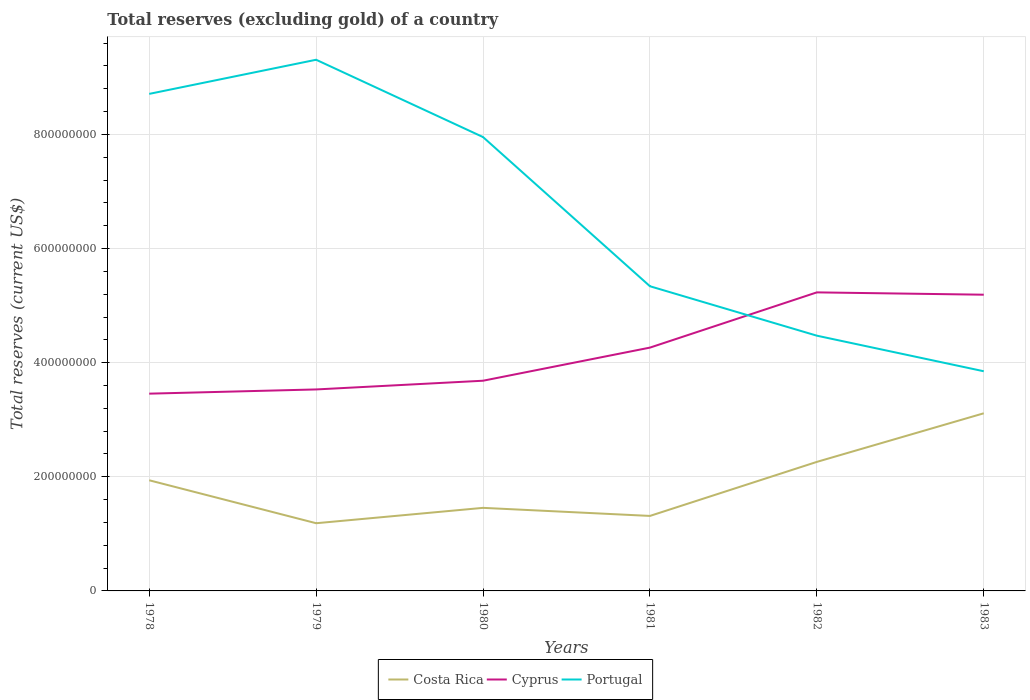How many different coloured lines are there?
Your answer should be compact. 3. Across all years, what is the maximum total reserves (excluding gold) in Costa Rica?
Your response must be concise. 1.19e+08. In which year was the total reserves (excluding gold) in Costa Rica maximum?
Offer a terse response. 1979. What is the total total reserves (excluding gold) in Portugal in the graph?
Offer a terse response. 4.24e+08. What is the difference between the highest and the second highest total reserves (excluding gold) in Portugal?
Provide a succinct answer. 5.46e+08. Is the total reserves (excluding gold) in Costa Rica strictly greater than the total reserves (excluding gold) in Portugal over the years?
Give a very brief answer. Yes. How many lines are there?
Give a very brief answer. 3. Are the values on the major ticks of Y-axis written in scientific E-notation?
Your answer should be very brief. No. How many legend labels are there?
Your answer should be very brief. 3. What is the title of the graph?
Offer a terse response. Total reserves (excluding gold) of a country. Does "Kyrgyz Republic" appear as one of the legend labels in the graph?
Keep it short and to the point. No. What is the label or title of the X-axis?
Offer a terse response. Years. What is the label or title of the Y-axis?
Offer a terse response. Total reserves (current US$). What is the Total reserves (current US$) in Costa Rica in 1978?
Your answer should be compact. 1.94e+08. What is the Total reserves (current US$) in Cyprus in 1978?
Your answer should be very brief. 3.46e+08. What is the Total reserves (current US$) of Portugal in 1978?
Your answer should be very brief. 8.71e+08. What is the Total reserves (current US$) of Costa Rica in 1979?
Keep it short and to the point. 1.19e+08. What is the Total reserves (current US$) of Cyprus in 1979?
Keep it short and to the point. 3.53e+08. What is the Total reserves (current US$) of Portugal in 1979?
Your answer should be very brief. 9.31e+08. What is the Total reserves (current US$) of Costa Rica in 1980?
Make the answer very short. 1.46e+08. What is the Total reserves (current US$) of Cyprus in 1980?
Offer a terse response. 3.68e+08. What is the Total reserves (current US$) of Portugal in 1980?
Give a very brief answer. 7.95e+08. What is the Total reserves (current US$) in Costa Rica in 1981?
Your answer should be compact. 1.31e+08. What is the Total reserves (current US$) in Cyprus in 1981?
Make the answer very short. 4.26e+08. What is the Total reserves (current US$) of Portugal in 1981?
Your answer should be very brief. 5.34e+08. What is the Total reserves (current US$) of Costa Rica in 1982?
Your response must be concise. 2.26e+08. What is the Total reserves (current US$) in Cyprus in 1982?
Keep it short and to the point. 5.23e+08. What is the Total reserves (current US$) of Portugal in 1982?
Ensure brevity in your answer.  4.47e+08. What is the Total reserves (current US$) in Costa Rica in 1983?
Offer a terse response. 3.11e+08. What is the Total reserves (current US$) in Cyprus in 1983?
Offer a very short reply. 5.19e+08. What is the Total reserves (current US$) of Portugal in 1983?
Offer a terse response. 3.85e+08. Across all years, what is the maximum Total reserves (current US$) in Costa Rica?
Provide a succinct answer. 3.11e+08. Across all years, what is the maximum Total reserves (current US$) in Cyprus?
Provide a succinct answer. 5.23e+08. Across all years, what is the maximum Total reserves (current US$) of Portugal?
Your answer should be very brief. 9.31e+08. Across all years, what is the minimum Total reserves (current US$) in Costa Rica?
Offer a very short reply. 1.19e+08. Across all years, what is the minimum Total reserves (current US$) in Cyprus?
Ensure brevity in your answer.  3.46e+08. Across all years, what is the minimum Total reserves (current US$) of Portugal?
Your answer should be very brief. 3.85e+08. What is the total Total reserves (current US$) in Costa Rica in the graph?
Ensure brevity in your answer.  1.13e+09. What is the total Total reserves (current US$) in Cyprus in the graph?
Your answer should be compact. 2.54e+09. What is the total Total reserves (current US$) in Portugal in the graph?
Provide a succinct answer. 3.96e+09. What is the difference between the Total reserves (current US$) in Costa Rica in 1978 and that in 1979?
Ensure brevity in your answer.  7.53e+07. What is the difference between the Total reserves (current US$) of Cyprus in 1978 and that in 1979?
Provide a short and direct response. -7.38e+06. What is the difference between the Total reserves (current US$) in Portugal in 1978 and that in 1979?
Provide a succinct answer. -5.98e+07. What is the difference between the Total reserves (current US$) in Costa Rica in 1978 and that in 1980?
Your answer should be very brief. 4.83e+07. What is the difference between the Total reserves (current US$) of Cyprus in 1978 and that in 1980?
Offer a very short reply. -2.27e+07. What is the difference between the Total reserves (current US$) of Portugal in 1978 and that in 1980?
Offer a terse response. 7.57e+07. What is the difference between the Total reserves (current US$) in Costa Rica in 1978 and that in 1981?
Your answer should be very brief. 6.25e+07. What is the difference between the Total reserves (current US$) in Cyprus in 1978 and that in 1981?
Your answer should be compact. -8.07e+07. What is the difference between the Total reserves (current US$) of Portugal in 1978 and that in 1981?
Your answer should be very brief. 3.37e+08. What is the difference between the Total reserves (current US$) of Costa Rica in 1978 and that in 1982?
Offer a very short reply. -3.22e+07. What is the difference between the Total reserves (current US$) in Cyprus in 1978 and that in 1982?
Your answer should be very brief. -1.77e+08. What is the difference between the Total reserves (current US$) of Portugal in 1978 and that in 1982?
Give a very brief answer. 4.24e+08. What is the difference between the Total reserves (current US$) in Costa Rica in 1978 and that in 1983?
Make the answer very short. -1.17e+08. What is the difference between the Total reserves (current US$) of Cyprus in 1978 and that in 1983?
Offer a very short reply. -1.73e+08. What is the difference between the Total reserves (current US$) in Portugal in 1978 and that in 1983?
Provide a succinct answer. 4.86e+08. What is the difference between the Total reserves (current US$) of Costa Rica in 1979 and that in 1980?
Your answer should be compact. -2.69e+07. What is the difference between the Total reserves (current US$) of Cyprus in 1979 and that in 1980?
Offer a very short reply. -1.53e+07. What is the difference between the Total reserves (current US$) of Portugal in 1979 and that in 1980?
Your response must be concise. 1.35e+08. What is the difference between the Total reserves (current US$) of Costa Rica in 1979 and that in 1981?
Keep it short and to the point. -1.28e+07. What is the difference between the Total reserves (current US$) of Cyprus in 1979 and that in 1981?
Your answer should be very brief. -7.33e+07. What is the difference between the Total reserves (current US$) in Portugal in 1979 and that in 1981?
Your response must be concise. 3.97e+08. What is the difference between the Total reserves (current US$) in Costa Rica in 1979 and that in 1982?
Make the answer very short. -1.07e+08. What is the difference between the Total reserves (current US$) in Cyprus in 1979 and that in 1982?
Give a very brief answer. -1.70e+08. What is the difference between the Total reserves (current US$) in Portugal in 1979 and that in 1982?
Ensure brevity in your answer.  4.84e+08. What is the difference between the Total reserves (current US$) of Costa Rica in 1979 and that in 1983?
Give a very brief answer. -1.93e+08. What is the difference between the Total reserves (current US$) of Cyprus in 1979 and that in 1983?
Your answer should be very brief. -1.66e+08. What is the difference between the Total reserves (current US$) in Portugal in 1979 and that in 1983?
Give a very brief answer. 5.46e+08. What is the difference between the Total reserves (current US$) of Costa Rica in 1980 and that in 1981?
Provide a short and direct response. 1.42e+07. What is the difference between the Total reserves (current US$) of Cyprus in 1980 and that in 1981?
Keep it short and to the point. -5.80e+07. What is the difference between the Total reserves (current US$) of Portugal in 1980 and that in 1981?
Ensure brevity in your answer.  2.61e+08. What is the difference between the Total reserves (current US$) in Costa Rica in 1980 and that in 1982?
Keep it short and to the point. -8.05e+07. What is the difference between the Total reserves (current US$) in Cyprus in 1980 and that in 1982?
Provide a succinct answer. -1.55e+08. What is the difference between the Total reserves (current US$) of Portugal in 1980 and that in 1982?
Give a very brief answer. 3.48e+08. What is the difference between the Total reserves (current US$) in Costa Rica in 1980 and that in 1983?
Your answer should be compact. -1.66e+08. What is the difference between the Total reserves (current US$) of Cyprus in 1980 and that in 1983?
Your answer should be compact. -1.51e+08. What is the difference between the Total reserves (current US$) of Portugal in 1980 and that in 1983?
Make the answer very short. 4.10e+08. What is the difference between the Total reserves (current US$) of Costa Rica in 1981 and that in 1982?
Your response must be concise. -9.47e+07. What is the difference between the Total reserves (current US$) in Cyprus in 1981 and that in 1982?
Give a very brief answer. -9.68e+07. What is the difference between the Total reserves (current US$) in Portugal in 1981 and that in 1982?
Your response must be concise. 8.66e+07. What is the difference between the Total reserves (current US$) in Costa Rica in 1981 and that in 1983?
Your answer should be very brief. -1.80e+08. What is the difference between the Total reserves (current US$) in Cyprus in 1981 and that in 1983?
Provide a short and direct response. -9.27e+07. What is the difference between the Total reserves (current US$) of Portugal in 1981 and that in 1983?
Offer a very short reply. 1.49e+08. What is the difference between the Total reserves (current US$) in Costa Rica in 1982 and that in 1983?
Your answer should be very brief. -8.52e+07. What is the difference between the Total reserves (current US$) of Cyprus in 1982 and that in 1983?
Your answer should be very brief. 4.10e+06. What is the difference between the Total reserves (current US$) of Portugal in 1982 and that in 1983?
Your answer should be very brief. 6.23e+07. What is the difference between the Total reserves (current US$) of Costa Rica in 1978 and the Total reserves (current US$) of Cyprus in 1979?
Your response must be concise. -1.59e+08. What is the difference between the Total reserves (current US$) in Costa Rica in 1978 and the Total reserves (current US$) in Portugal in 1979?
Your answer should be very brief. -7.37e+08. What is the difference between the Total reserves (current US$) of Cyprus in 1978 and the Total reserves (current US$) of Portugal in 1979?
Give a very brief answer. -5.85e+08. What is the difference between the Total reserves (current US$) in Costa Rica in 1978 and the Total reserves (current US$) in Cyprus in 1980?
Give a very brief answer. -1.74e+08. What is the difference between the Total reserves (current US$) in Costa Rica in 1978 and the Total reserves (current US$) in Portugal in 1980?
Give a very brief answer. -6.01e+08. What is the difference between the Total reserves (current US$) in Cyprus in 1978 and the Total reserves (current US$) in Portugal in 1980?
Your answer should be very brief. -4.50e+08. What is the difference between the Total reserves (current US$) of Costa Rica in 1978 and the Total reserves (current US$) of Cyprus in 1981?
Your response must be concise. -2.32e+08. What is the difference between the Total reserves (current US$) of Costa Rica in 1978 and the Total reserves (current US$) of Portugal in 1981?
Offer a very short reply. -3.40e+08. What is the difference between the Total reserves (current US$) of Cyprus in 1978 and the Total reserves (current US$) of Portugal in 1981?
Ensure brevity in your answer.  -1.88e+08. What is the difference between the Total reserves (current US$) of Costa Rica in 1978 and the Total reserves (current US$) of Cyprus in 1982?
Offer a terse response. -3.29e+08. What is the difference between the Total reserves (current US$) of Costa Rica in 1978 and the Total reserves (current US$) of Portugal in 1982?
Keep it short and to the point. -2.53e+08. What is the difference between the Total reserves (current US$) of Cyprus in 1978 and the Total reserves (current US$) of Portugal in 1982?
Give a very brief answer. -1.02e+08. What is the difference between the Total reserves (current US$) in Costa Rica in 1978 and the Total reserves (current US$) in Cyprus in 1983?
Give a very brief answer. -3.25e+08. What is the difference between the Total reserves (current US$) in Costa Rica in 1978 and the Total reserves (current US$) in Portugal in 1983?
Offer a terse response. -1.91e+08. What is the difference between the Total reserves (current US$) in Cyprus in 1978 and the Total reserves (current US$) in Portugal in 1983?
Offer a terse response. -3.93e+07. What is the difference between the Total reserves (current US$) of Costa Rica in 1979 and the Total reserves (current US$) of Cyprus in 1980?
Give a very brief answer. -2.50e+08. What is the difference between the Total reserves (current US$) of Costa Rica in 1979 and the Total reserves (current US$) of Portugal in 1980?
Offer a very short reply. -6.77e+08. What is the difference between the Total reserves (current US$) of Cyprus in 1979 and the Total reserves (current US$) of Portugal in 1980?
Provide a succinct answer. -4.42e+08. What is the difference between the Total reserves (current US$) of Costa Rica in 1979 and the Total reserves (current US$) of Cyprus in 1981?
Ensure brevity in your answer.  -3.08e+08. What is the difference between the Total reserves (current US$) of Costa Rica in 1979 and the Total reserves (current US$) of Portugal in 1981?
Offer a terse response. -4.15e+08. What is the difference between the Total reserves (current US$) in Cyprus in 1979 and the Total reserves (current US$) in Portugal in 1981?
Your response must be concise. -1.81e+08. What is the difference between the Total reserves (current US$) of Costa Rica in 1979 and the Total reserves (current US$) of Cyprus in 1982?
Provide a succinct answer. -4.05e+08. What is the difference between the Total reserves (current US$) in Costa Rica in 1979 and the Total reserves (current US$) in Portugal in 1982?
Provide a short and direct response. -3.29e+08. What is the difference between the Total reserves (current US$) in Cyprus in 1979 and the Total reserves (current US$) in Portugal in 1982?
Ensure brevity in your answer.  -9.42e+07. What is the difference between the Total reserves (current US$) of Costa Rica in 1979 and the Total reserves (current US$) of Cyprus in 1983?
Give a very brief answer. -4.00e+08. What is the difference between the Total reserves (current US$) of Costa Rica in 1979 and the Total reserves (current US$) of Portugal in 1983?
Your answer should be very brief. -2.66e+08. What is the difference between the Total reserves (current US$) of Cyprus in 1979 and the Total reserves (current US$) of Portugal in 1983?
Your answer should be compact. -3.19e+07. What is the difference between the Total reserves (current US$) of Costa Rica in 1980 and the Total reserves (current US$) of Cyprus in 1981?
Your answer should be very brief. -2.81e+08. What is the difference between the Total reserves (current US$) in Costa Rica in 1980 and the Total reserves (current US$) in Portugal in 1981?
Make the answer very short. -3.88e+08. What is the difference between the Total reserves (current US$) of Cyprus in 1980 and the Total reserves (current US$) of Portugal in 1981?
Make the answer very short. -1.66e+08. What is the difference between the Total reserves (current US$) of Costa Rica in 1980 and the Total reserves (current US$) of Cyprus in 1982?
Your answer should be compact. -3.78e+08. What is the difference between the Total reserves (current US$) of Costa Rica in 1980 and the Total reserves (current US$) of Portugal in 1982?
Your answer should be very brief. -3.02e+08. What is the difference between the Total reserves (current US$) in Cyprus in 1980 and the Total reserves (current US$) in Portugal in 1982?
Provide a succinct answer. -7.89e+07. What is the difference between the Total reserves (current US$) of Costa Rica in 1980 and the Total reserves (current US$) of Cyprus in 1983?
Offer a very short reply. -3.74e+08. What is the difference between the Total reserves (current US$) in Costa Rica in 1980 and the Total reserves (current US$) in Portugal in 1983?
Your answer should be very brief. -2.39e+08. What is the difference between the Total reserves (current US$) of Cyprus in 1980 and the Total reserves (current US$) of Portugal in 1983?
Keep it short and to the point. -1.66e+07. What is the difference between the Total reserves (current US$) in Costa Rica in 1981 and the Total reserves (current US$) in Cyprus in 1982?
Give a very brief answer. -3.92e+08. What is the difference between the Total reserves (current US$) of Costa Rica in 1981 and the Total reserves (current US$) of Portugal in 1982?
Your response must be concise. -3.16e+08. What is the difference between the Total reserves (current US$) in Cyprus in 1981 and the Total reserves (current US$) in Portugal in 1982?
Provide a succinct answer. -2.09e+07. What is the difference between the Total reserves (current US$) in Costa Rica in 1981 and the Total reserves (current US$) in Cyprus in 1983?
Provide a succinct answer. -3.88e+08. What is the difference between the Total reserves (current US$) in Costa Rica in 1981 and the Total reserves (current US$) in Portugal in 1983?
Ensure brevity in your answer.  -2.54e+08. What is the difference between the Total reserves (current US$) of Cyprus in 1981 and the Total reserves (current US$) of Portugal in 1983?
Your answer should be very brief. 4.14e+07. What is the difference between the Total reserves (current US$) of Costa Rica in 1982 and the Total reserves (current US$) of Cyprus in 1983?
Provide a succinct answer. -2.93e+08. What is the difference between the Total reserves (current US$) in Costa Rica in 1982 and the Total reserves (current US$) in Portugal in 1983?
Keep it short and to the point. -1.59e+08. What is the difference between the Total reserves (current US$) in Cyprus in 1982 and the Total reserves (current US$) in Portugal in 1983?
Ensure brevity in your answer.  1.38e+08. What is the average Total reserves (current US$) of Costa Rica per year?
Ensure brevity in your answer.  1.88e+08. What is the average Total reserves (current US$) in Cyprus per year?
Your answer should be compact. 4.23e+08. What is the average Total reserves (current US$) of Portugal per year?
Your response must be concise. 6.61e+08. In the year 1978, what is the difference between the Total reserves (current US$) of Costa Rica and Total reserves (current US$) of Cyprus?
Provide a succinct answer. -1.52e+08. In the year 1978, what is the difference between the Total reserves (current US$) of Costa Rica and Total reserves (current US$) of Portugal?
Provide a short and direct response. -6.77e+08. In the year 1978, what is the difference between the Total reserves (current US$) in Cyprus and Total reserves (current US$) in Portugal?
Your answer should be very brief. -5.25e+08. In the year 1979, what is the difference between the Total reserves (current US$) of Costa Rica and Total reserves (current US$) of Cyprus?
Your answer should be compact. -2.34e+08. In the year 1979, what is the difference between the Total reserves (current US$) in Costa Rica and Total reserves (current US$) in Portugal?
Offer a very short reply. -8.12e+08. In the year 1979, what is the difference between the Total reserves (current US$) of Cyprus and Total reserves (current US$) of Portugal?
Ensure brevity in your answer.  -5.78e+08. In the year 1980, what is the difference between the Total reserves (current US$) in Costa Rica and Total reserves (current US$) in Cyprus?
Your answer should be very brief. -2.23e+08. In the year 1980, what is the difference between the Total reserves (current US$) in Costa Rica and Total reserves (current US$) in Portugal?
Your response must be concise. -6.50e+08. In the year 1980, what is the difference between the Total reserves (current US$) of Cyprus and Total reserves (current US$) of Portugal?
Offer a very short reply. -4.27e+08. In the year 1981, what is the difference between the Total reserves (current US$) of Costa Rica and Total reserves (current US$) of Cyprus?
Give a very brief answer. -2.95e+08. In the year 1981, what is the difference between the Total reserves (current US$) in Costa Rica and Total reserves (current US$) in Portugal?
Offer a terse response. -4.02e+08. In the year 1981, what is the difference between the Total reserves (current US$) in Cyprus and Total reserves (current US$) in Portugal?
Provide a short and direct response. -1.08e+08. In the year 1982, what is the difference between the Total reserves (current US$) in Costa Rica and Total reserves (current US$) in Cyprus?
Ensure brevity in your answer.  -2.97e+08. In the year 1982, what is the difference between the Total reserves (current US$) in Costa Rica and Total reserves (current US$) in Portugal?
Your response must be concise. -2.21e+08. In the year 1982, what is the difference between the Total reserves (current US$) of Cyprus and Total reserves (current US$) of Portugal?
Offer a very short reply. 7.59e+07. In the year 1983, what is the difference between the Total reserves (current US$) of Costa Rica and Total reserves (current US$) of Cyprus?
Make the answer very short. -2.08e+08. In the year 1983, what is the difference between the Total reserves (current US$) of Costa Rica and Total reserves (current US$) of Portugal?
Ensure brevity in your answer.  -7.37e+07. In the year 1983, what is the difference between the Total reserves (current US$) in Cyprus and Total reserves (current US$) in Portugal?
Provide a short and direct response. 1.34e+08. What is the ratio of the Total reserves (current US$) of Costa Rica in 1978 to that in 1979?
Keep it short and to the point. 1.63. What is the ratio of the Total reserves (current US$) of Cyprus in 1978 to that in 1979?
Make the answer very short. 0.98. What is the ratio of the Total reserves (current US$) in Portugal in 1978 to that in 1979?
Offer a very short reply. 0.94. What is the ratio of the Total reserves (current US$) in Costa Rica in 1978 to that in 1980?
Provide a short and direct response. 1.33. What is the ratio of the Total reserves (current US$) of Cyprus in 1978 to that in 1980?
Your answer should be compact. 0.94. What is the ratio of the Total reserves (current US$) of Portugal in 1978 to that in 1980?
Ensure brevity in your answer.  1.1. What is the ratio of the Total reserves (current US$) in Costa Rica in 1978 to that in 1981?
Your answer should be very brief. 1.48. What is the ratio of the Total reserves (current US$) of Cyprus in 1978 to that in 1981?
Your response must be concise. 0.81. What is the ratio of the Total reserves (current US$) of Portugal in 1978 to that in 1981?
Give a very brief answer. 1.63. What is the ratio of the Total reserves (current US$) in Costa Rica in 1978 to that in 1982?
Give a very brief answer. 0.86. What is the ratio of the Total reserves (current US$) in Cyprus in 1978 to that in 1982?
Make the answer very short. 0.66. What is the ratio of the Total reserves (current US$) of Portugal in 1978 to that in 1982?
Provide a succinct answer. 1.95. What is the ratio of the Total reserves (current US$) in Costa Rica in 1978 to that in 1983?
Offer a terse response. 0.62. What is the ratio of the Total reserves (current US$) of Cyprus in 1978 to that in 1983?
Offer a terse response. 0.67. What is the ratio of the Total reserves (current US$) of Portugal in 1978 to that in 1983?
Your answer should be compact. 2.26. What is the ratio of the Total reserves (current US$) of Costa Rica in 1979 to that in 1980?
Your answer should be compact. 0.81. What is the ratio of the Total reserves (current US$) of Cyprus in 1979 to that in 1980?
Provide a succinct answer. 0.96. What is the ratio of the Total reserves (current US$) of Portugal in 1979 to that in 1980?
Give a very brief answer. 1.17. What is the ratio of the Total reserves (current US$) in Costa Rica in 1979 to that in 1981?
Your answer should be very brief. 0.9. What is the ratio of the Total reserves (current US$) of Cyprus in 1979 to that in 1981?
Offer a terse response. 0.83. What is the ratio of the Total reserves (current US$) of Portugal in 1979 to that in 1981?
Make the answer very short. 1.74. What is the ratio of the Total reserves (current US$) of Costa Rica in 1979 to that in 1982?
Make the answer very short. 0.52. What is the ratio of the Total reserves (current US$) in Cyprus in 1979 to that in 1982?
Make the answer very short. 0.67. What is the ratio of the Total reserves (current US$) in Portugal in 1979 to that in 1982?
Provide a succinct answer. 2.08. What is the ratio of the Total reserves (current US$) of Costa Rica in 1979 to that in 1983?
Your answer should be compact. 0.38. What is the ratio of the Total reserves (current US$) in Cyprus in 1979 to that in 1983?
Ensure brevity in your answer.  0.68. What is the ratio of the Total reserves (current US$) of Portugal in 1979 to that in 1983?
Ensure brevity in your answer.  2.42. What is the ratio of the Total reserves (current US$) in Costa Rica in 1980 to that in 1981?
Ensure brevity in your answer.  1.11. What is the ratio of the Total reserves (current US$) in Cyprus in 1980 to that in 1981?
Keep it short and to the point. 0.86. What is the ratio of the Total reserves (current US$) in Portugal in 1980 to that in 1981?
Ensure brevity in your answer.  1.49. What is the ratio of the Total reserves (current US$) of Costa Rica in 1980 to that in 1982?
Your answer should be compact. 0.64. What is the ratio of the Total reserves (current US$) in Cyprus in 1980 to that in 1982?
Ensure brevity in your answer.  0.7. What is the ratio of the Total reserves (current US$) of Portugal in 1980 to that in 1982?
Give a very brief answer. 1.78. What is the ratio of the Total reserves (current US$) in Costa Rica in 1980 to that in 1983?
Provide a succinct answer. 0.47. What is the ratio of the Total reserves (current US$) of Cyprus in 1980 to that in 1983?
Your answer should be very brief. 0.71. What is the ratio of the Total reserves (current US$) of Portugal in 1980 to that in 1983?
Offer a terse response. 2.07. What is the ratio of the Total reserves (current US$) in Costa Rica in 1981 to that in 1982?
Give a very brief answer. 0.58. What is the ratio of the Total reserves (current US$) in Cyprus in 1981 to that in 1982?
Your answer should be very brief. 0.81. What is the ratio of the Total reserves (current US$) of Portugal in 1981 to that in 1982?
Your answer should be compact. 1.19. What is the ratio of the Total reserves (current US$) in Costa Rica in 1981 to that in 1983?
Offer a terse response. 0.42. What is the ratio of the Total reserves (current US$) in Cyprus in 1981 to that in 1983?
Offer a terse response. 0.82. What is the ratio of the Total reserves (current US$) of Portugal in 1981 to that in 1983?
Offer a very short reply. 1.39. What is the ratio of the Total reserves (current US$) of Costa Rica in 1982 to that in 1983?
Provide a short and direct response. 0.73. What is the ratio of the Total reserves (current US$) in Cyprus in 1982 to that in 1983?
Keep it short and to the point. 1.01. What is the ratio of the Total reserves (current US$) of Portugal in 1982 to that in 1983?
Offer a terse response. 1.16. What is the difference between the highest and the second highest Total reserves (current US$) of Costa Rica?
Your answer should be compact. 8.52e+07. What is the difference between the highest and the second highest Total reserves (current US$) in Cyprus?
Offer a terse response. 4.10e+06. What is the difference between the highest and the second highest Total reserves (current US$) of Portugal?
Your answer should be very brief. 5.98e+07. What is the difference between the highest and the lowest Total reserves (current US$) of Costa Rica?
Your answer should be very brief. 1.93e+08. What is the difference between the highest and the lowest Total reserves (current US$) in Cyprus?
Offer a very short reply. 1.77e+08. What is the difference between the highest and the lowest Total reserves (current US$) in Portugal?
Offer a terse response. 5.46e+08. 